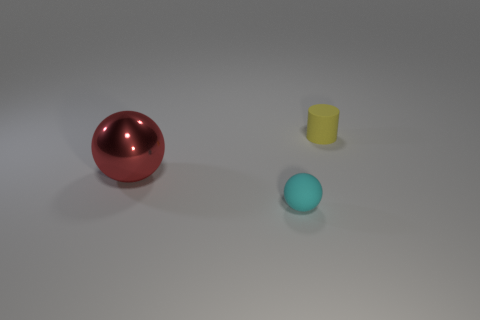What number of objects are right of the red shiny object and in front of the small cylinder?
Provide a short and direct response. 1. There is a thing right of the cyan rubber object; what shape is it?
Provide a short and direct response. Cylinder. How many cyan spheres have the same material as the tiny yellow object?
Provide a succinct answer. 1. Is the shape of the small yellow thing the same as the tiny thing in front of the red ball?
Give a very brief answer. No. There is a small yellow cylinder that is behind the tiny object in front of the large sphere; is there a large object on the right side of it?
Provide a short and direct response. No. What is the size of the object behind the big metal thing?
Offer a terse response. Small. There is a yellow thing that is the same size as the rubber sphere; what is its material?
Give a very brief answer. Rubber. Do the red thing and the small cyan thing have the same shape?
Keep it short and to the point. Yes. How many things are either tiny rubber cylinders or things right of the cyan object?
Make the answer very short. 1. Is the size of the object right of the cyan object the same as the large metallic object?
Provide a succinct answer. No. 